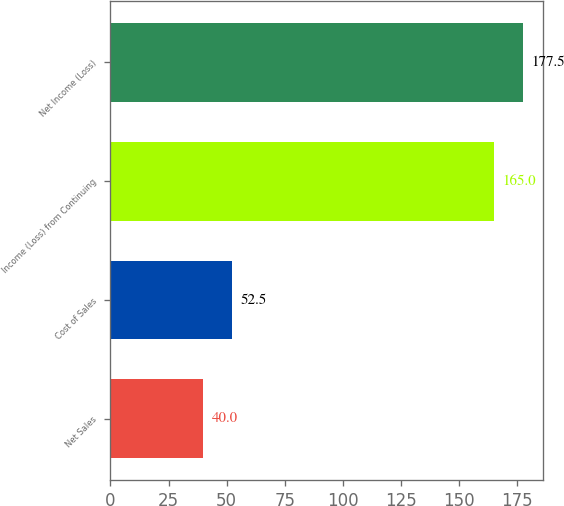Convert chart to OTSL. <chart><loc_0><loc_0><loc_500><loc_500><bar_chart><fcel>Net Sales<fcel>Cost of Sales<fcel>Income (Loss) from Continuing<fcel>Net Income (Loss)<nl><fcel>40<fcel>52.5<fcel>165<fcel>177.5<nl></chart> 